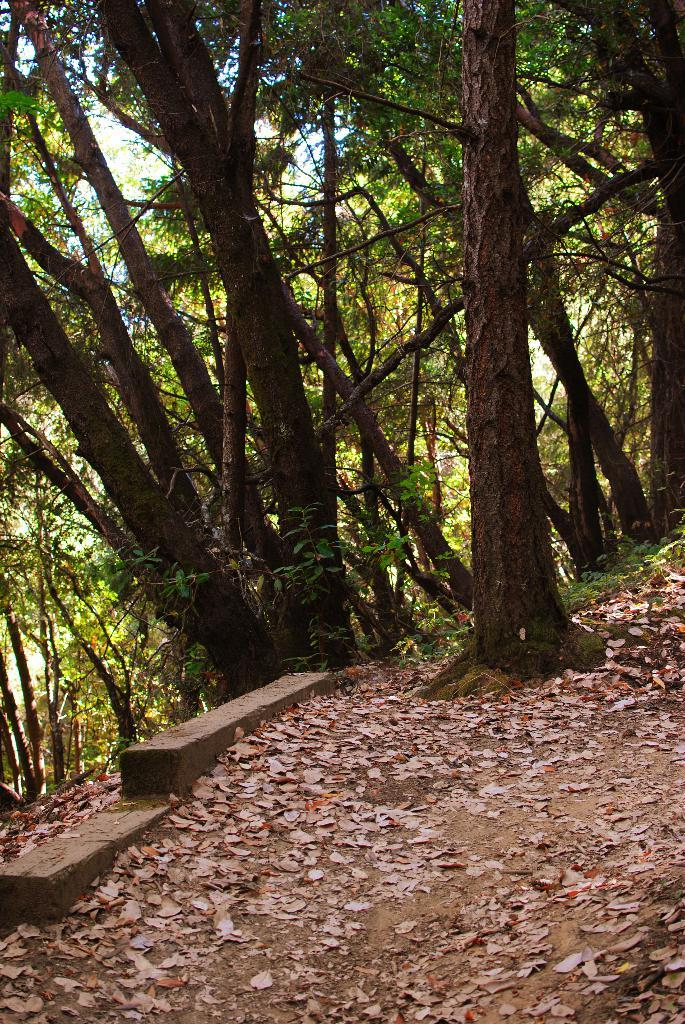What type of vegetation can be seen in the image? There are trees in the image. What can be found on the ground beneath the trees? Leaves are present on the ground in the image. What type of thrill can be experienced by the ant in the image? There is no ant present in the image, so it is not possible to determine what type of thrill might be experienced. 